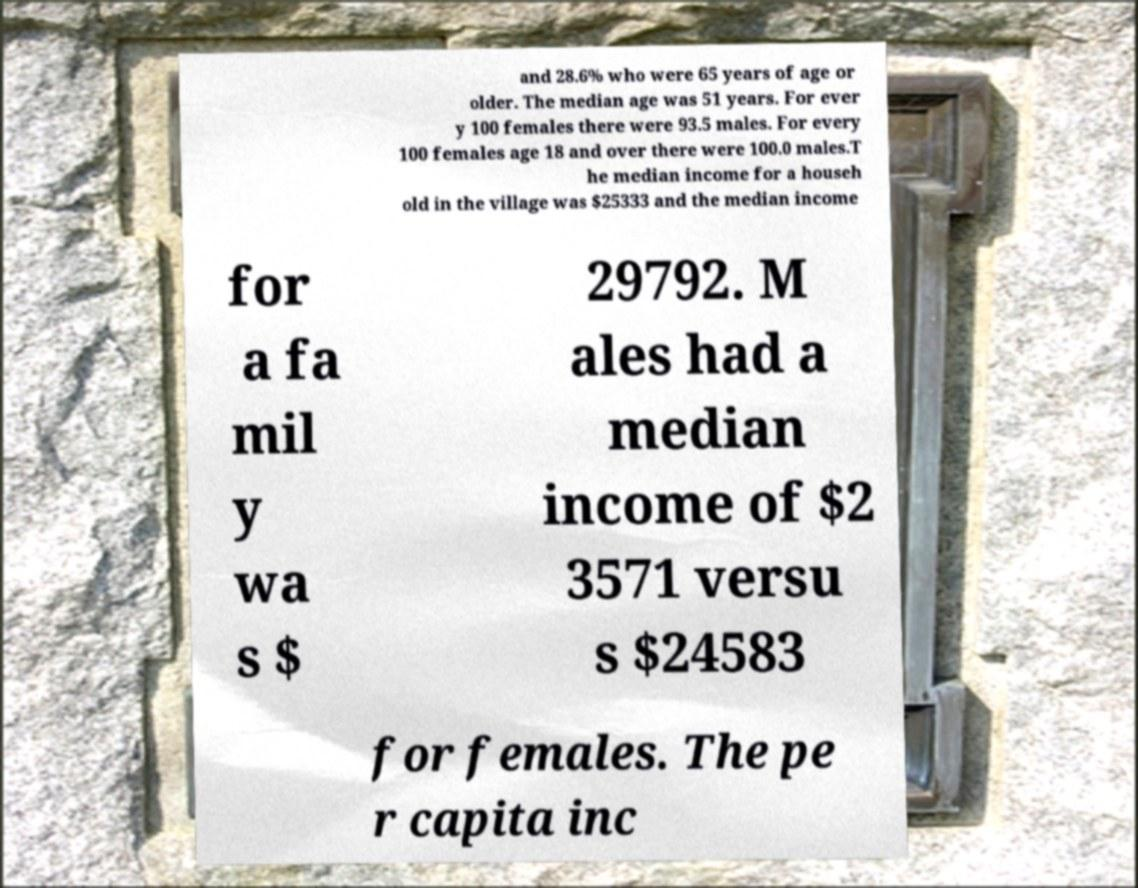Can you accurately transcribe the text from the provided image for me? and 28.6% who were 65 years of age or older. The median age was 51 years. For ever y 100 females there were 93.5 males. For every 100 females age 18 and over there were 100.0 males.T he median income for a househ old in the village was $25333 and the median income for a fa mil y wa s $ 29792. M ales had a median income of $2 3571 versu s $24583 for females. The pe r capita inc 